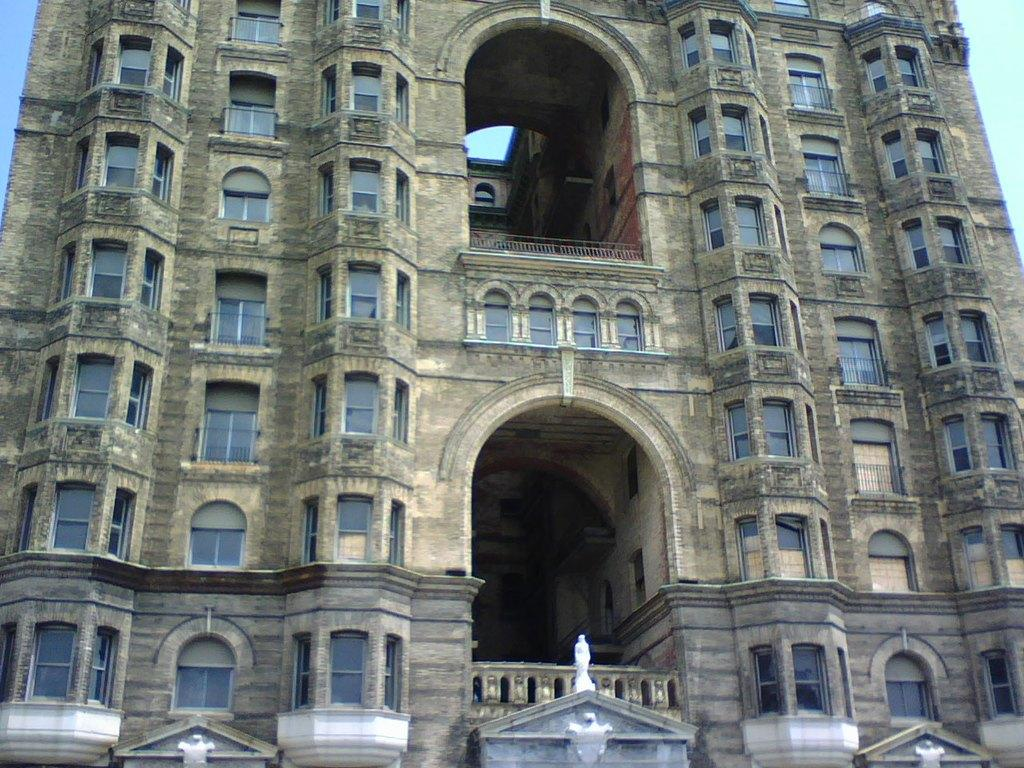What is the main subject of the image? The main subject of the image is a building. Can you describe the building in the image? Unfortunately, the provided facts do not include any details about the building's appearance or features. What type of quilt is the father using to cover the building in the image? There is no father or quilt present in the image, and therefore no such activity can be observed. 